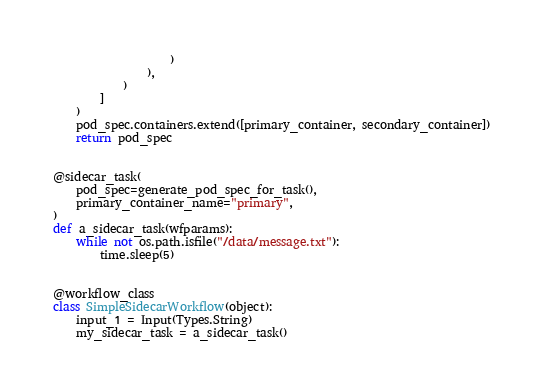Convert code to text. <code><loc_0><loc_0><loc_500><loc_500><_Python_>                    )
                ),
            )
        ]
    )
    pod_spec.containers.extend([primary_container, secondary_container])
    return pod_spec


@sidecar_task(
    pod_spec=generate_pod_spec_for_task(),
    primary_container_name="primary",
)
def a_sidecar_task(wfparams):
    while not os.path.isfile("/data/message.txt"):
        time.sleep(5)


@workflow_class
class SimpleSidecarWorkflow(object):
    input_1 = Input(Types.String)
    my_sidecar_task = a_sidecar_task()
</code> 